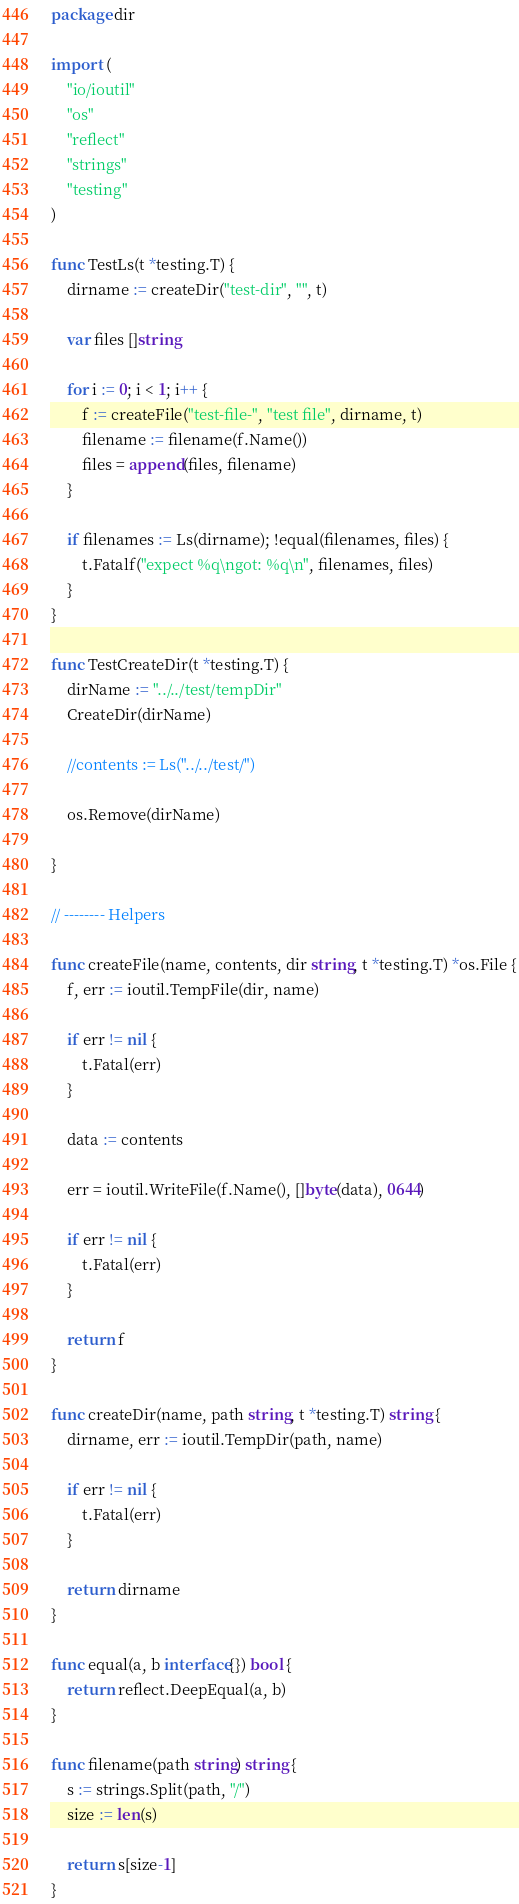<code> <loc_0><loc_0><loc_500><loc_500><_Go_>package dir

import (
	"io/ioutil"
	"os"
	"reflect"
	"strings"
	"testing"
)

func TestLs(t *testing.T) {
	dirname := createDir("test-dir", "", t)

	var files []string

	for i := 0; i < 1; i++ {
		f := createFile("test-file-", "test file", dirname, t)
		filename := filename(f.Name())
		files = append(files, filename)
	}

	if filenames := Ls(dirname); !equal(filenames, files) {
		t.Fatalf("expect %q\ngot: %q\n", filenames, files)
	}
}

func TestCreateDir(t *testing.T) {
	dirName := "../../test/tempDir"
	CreateDir(dirName)

	//contents := Ls("../../test/")

	os.Remove(dirName)

}

// -------- Helpers

func createFile(name, contents, dir string, t *testing.T) *os.File {
	f, err := ioutil.TempFile(dir, name)

	if err != nil {
		t.Fatal(err)
	}

	data := contents

	err = ioutil.WriteFile(f.Name(), []byte(data), 0644)

	if err != nil {
		t.Fatal(err)
	}

	return f
}

func createDir(name, path string, t *testing.T) string {
	dirname, err := ioutil.TempDir(path, name)

	if err != nil {
		t.Fatal(err)
	}

	return dirname
}

func equal(a, b interface{}) bool {
	return reflect.DeepEqual(a, b)
}

func filename(path string) string {
	s := strings.Split(path, "/")
	size := len(s)

	return s[size-1]
}
</code> 